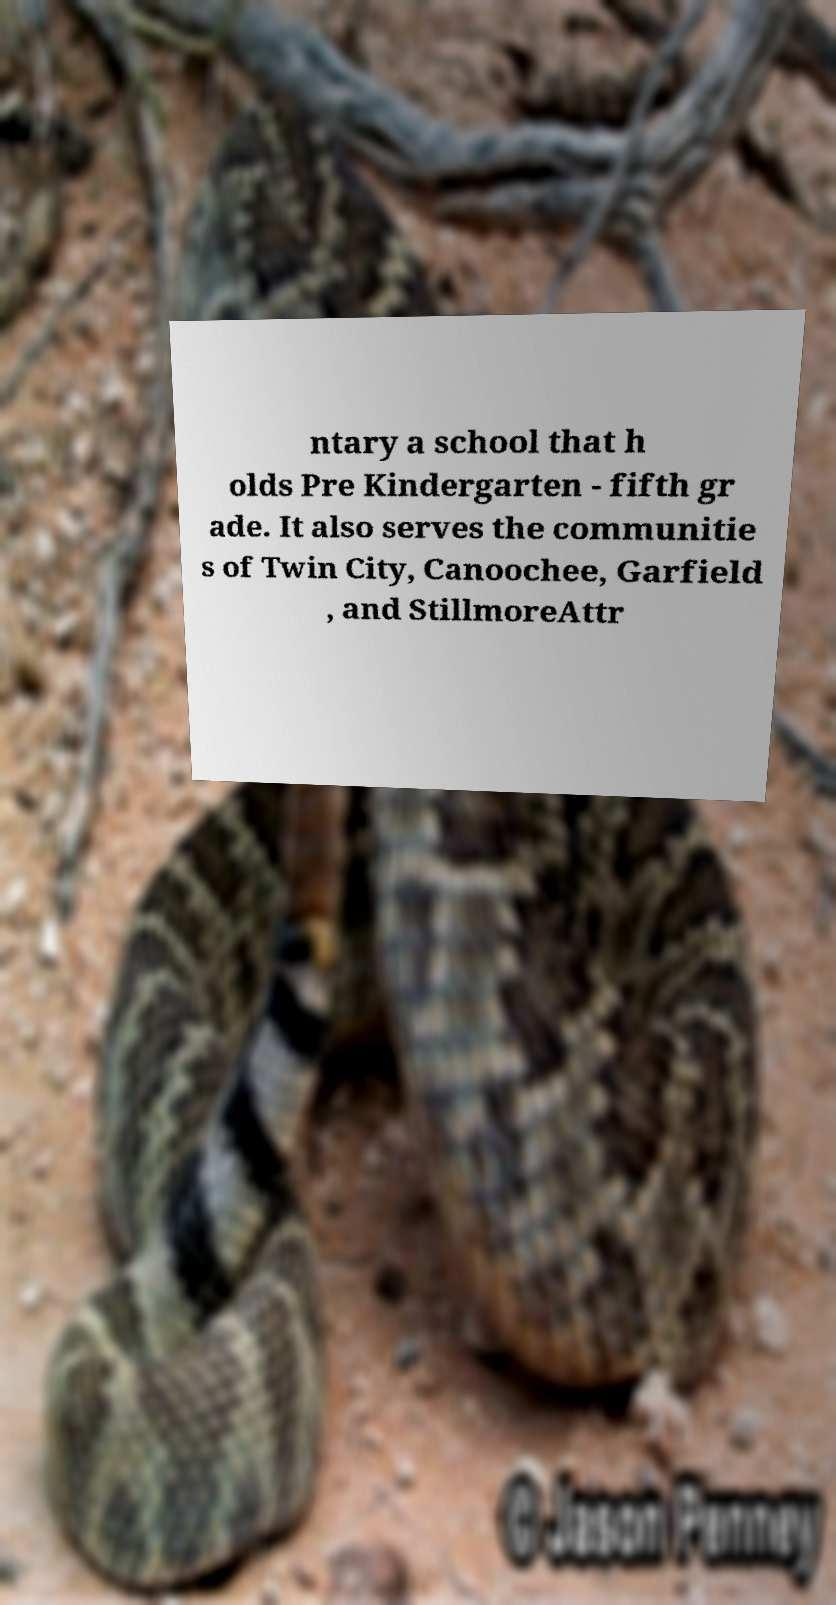Could you extract and type out the text from this image? ntary a school that h olds Pre Kindergarten - fifth gr ade. It also serves the communitie s of Twin City, Canoochee, Garfield , and StillmoreAttr 